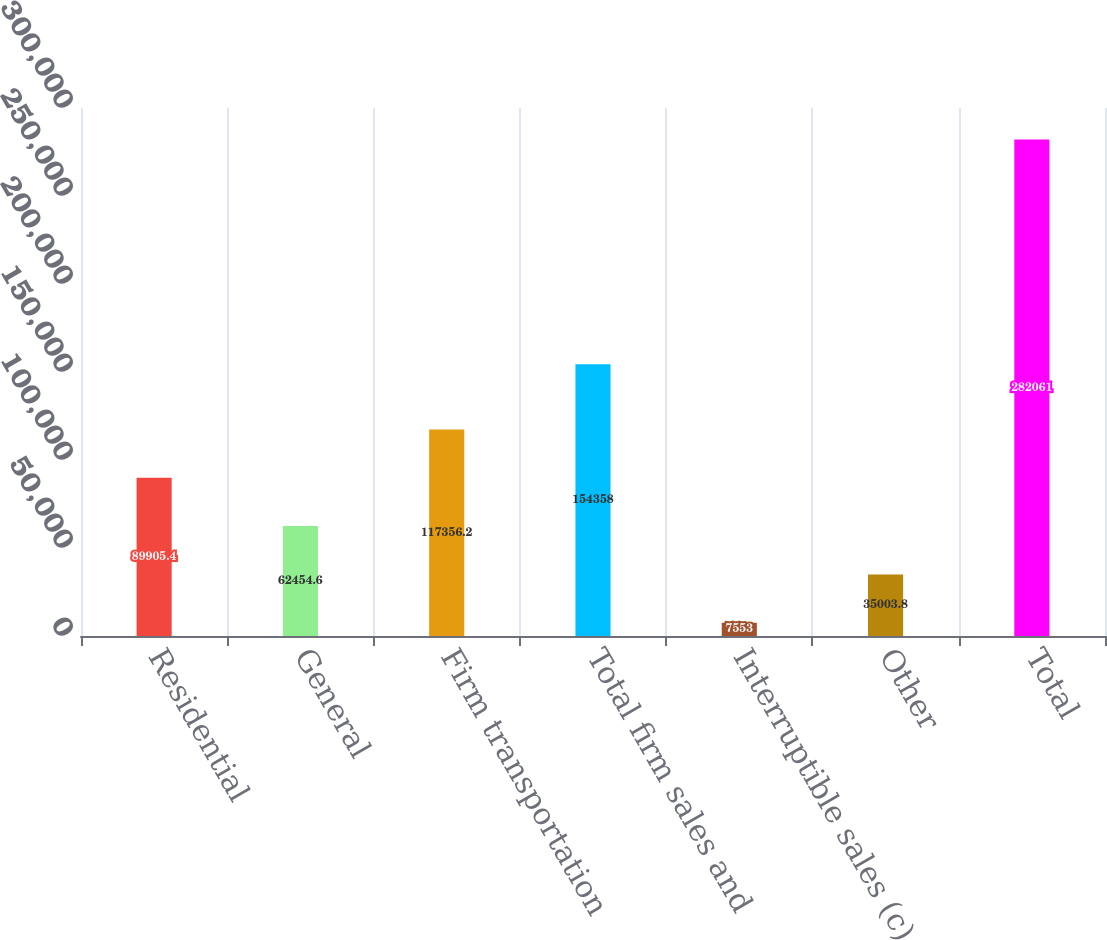<chart> <loc_0><loc_0><loc_500><loc_500><bar_chart><fcel>Residential<fcel>General<fcel>Firm transportation<fcel>Total firm sales and<fcel>Interruptible sales (c)<fcel>Other<fcel>Total<nl><fcel>89905.4<fcel>62454.6<fcel>117356<fcel>154358<fcel>7553<fcel>35003.8<fcel>282061<nl></chart> 